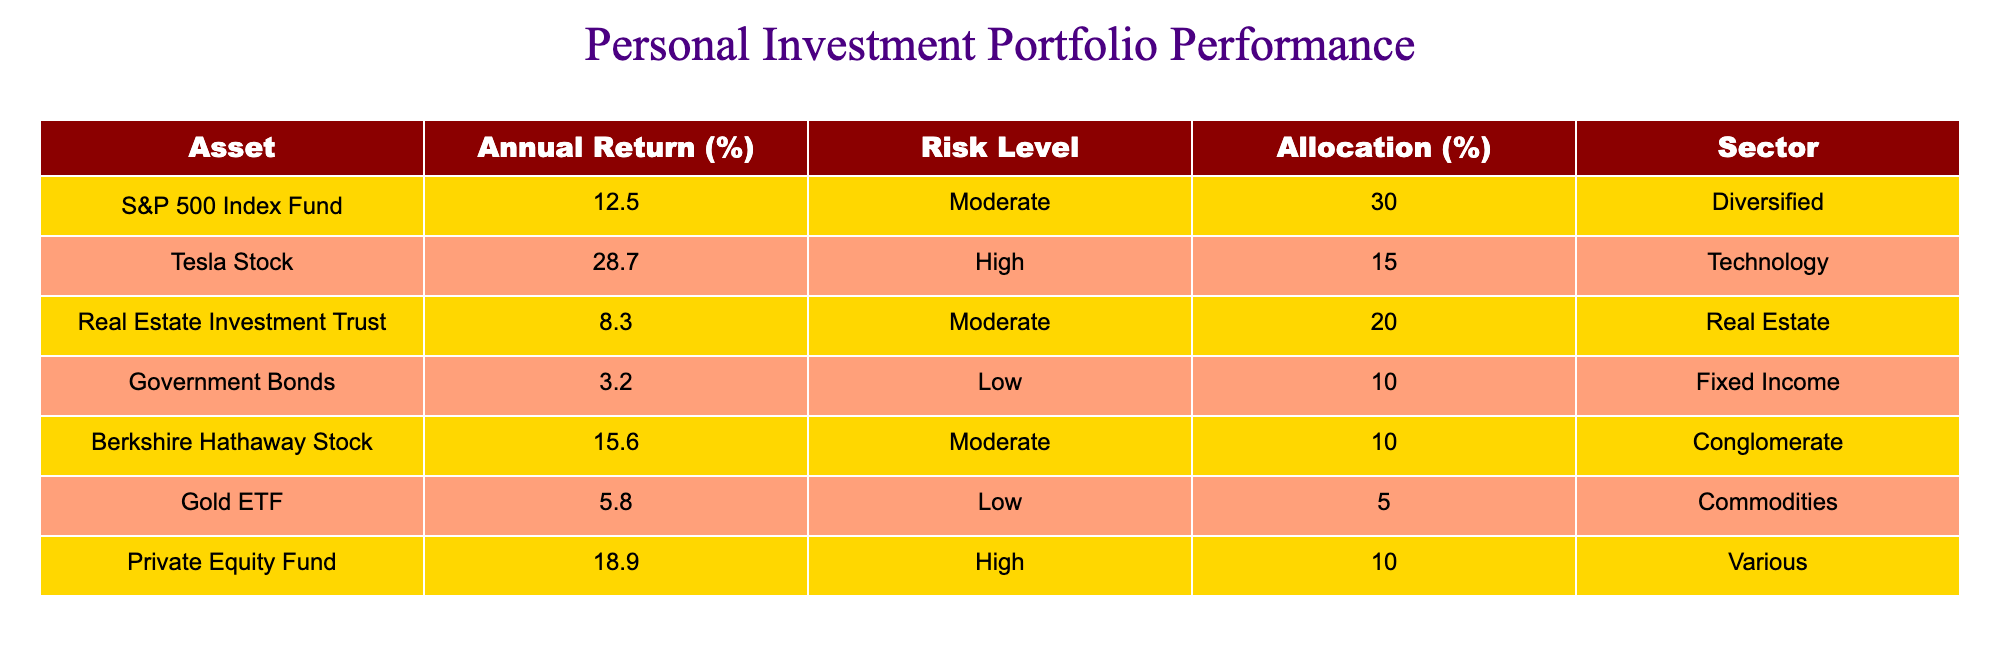What is the annual return of Tesla Stock? The table specifies that the annual return for Tesla Stock is listed as 28.7%.
Answer: 28.7% Which asset has the highest allocation percentage? Reviewing the allocation percentages, the S&P 500 Index Fund has the highest allocation at 30%.
Answer: 30% What is the average annual return of the assets categorized as "Moderate" risk level? The annual returns for the assets with moderate risk are 12.5% (S&P 500), 8.3% (Real Estate), and 15.6% (Berkshire Hathaway), which sums to 36.4%. Dividing by the number of assets (3) gives an average of 12.13%.
Answer: 12.13% Is there a High-risk asset with an allocation of less than 10%? The table shows that both Tesla Stock and Private Equity Fund are the only High-risk assets, with allocations of 15% and 10%, respectively. Therefore, there is no High-risk asset with an allocation less than 10%.
Answer: No What is the total allocation percentage for assets in the Technology sector? Only Tesla Stock is in the Technology sector, which has an allocation of 15%. Thus, the total allocation is 15%.
Answer: 15% What is the difference in annual returns between the asset with the highest return and the asset with the lowest return? The highest annual return is 28.7% (Tesla Stock) and the lowest is 3.2% (Government Bonds). The difference is 28.7% - 3.2% = 25.5%.
Answer: 25.5% Is Gold ETF considered a Low risk asset? According to the table, Gold ETF has a specified risk level of Low, confirming that it is indeed a Low risk asset.
Answer: Yes Which sector has the highest average return among all assets? To find the average return for each sector, we list the annual returns and respective weights, then calculate: Diversified - 12.5%, Technology - 28.7%, Real Estate - 8.3%, Fixed Income - 3.2%, and Commodities - 5.8%. The highest return is coming from the Technology sector (28.7%).
Answer: Technology 